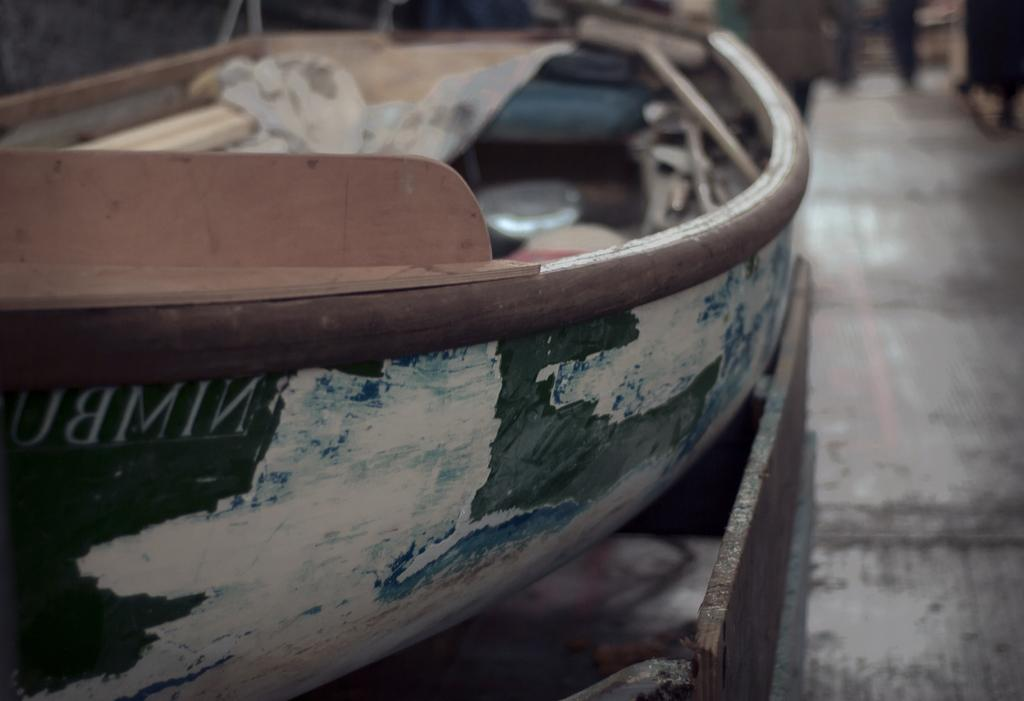What type of vehicle is in the image? There is an old boat in the image. Where is the boat located in the image? The boat is on the left side of the image. What type of dinner is being served on the boat in the image? There is no dinner or any indication of food in the image; it only features an old boat. Can you describe the wall surrounding the boat in the image? There is no wall present in the image; it only features an old boat on the left side. 